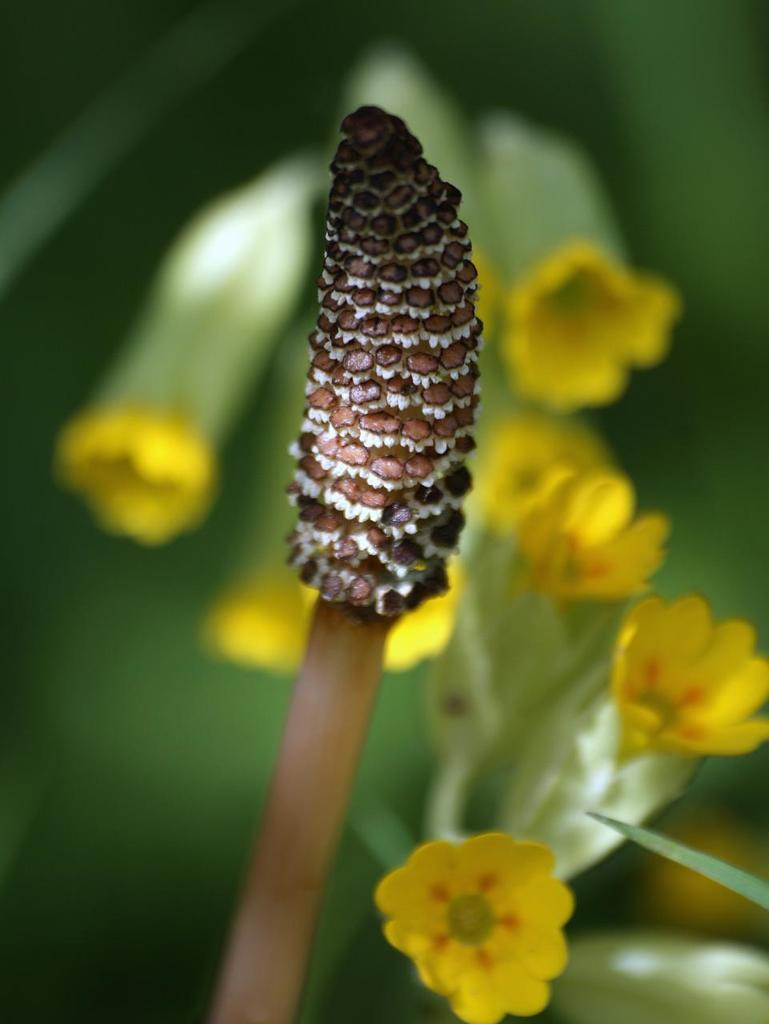What is the main subject in the center of the image? There is a flower in the center of the image. Can you describe the background of the image? There are flowers in the background of the image. Is there a girl driving a car down a slope in the image? No, there is no girl, car, or slope present in the image; it only features flowers. 